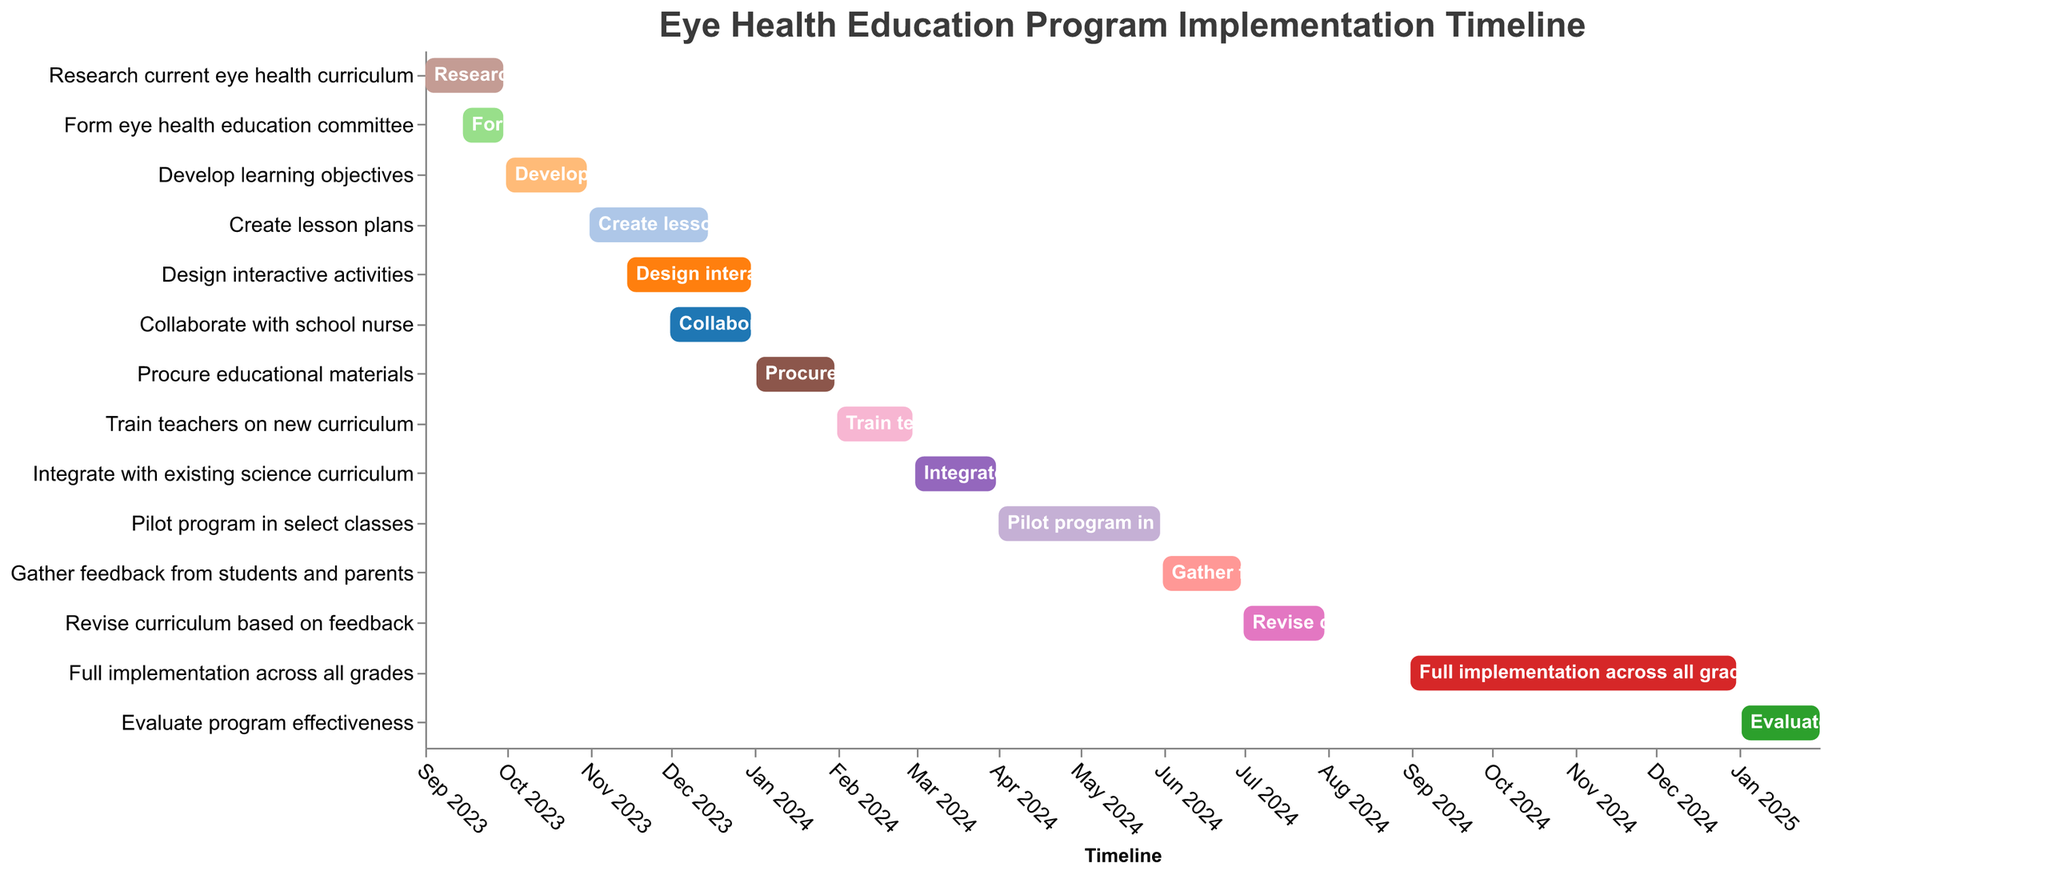What is the title of the figure? The title is usually located at the top of the figure. The title of this figure is "Eye Health Education Program Implementation Timeline".
Answer: Eye Health Education Program Implementation Timeline Which task is scheduled to start first? The task with the earliest start date is "Research current eye health curriculum," which starts on 2023-09-01.
Answer: Research current eye health curriculum When does the task "Create lesson plans" end? The task "Create lesson plans" ends on 2023-12-15, as indicated by the End Date for this task.
Answer: 2023-12-15 How many tasks are taking place in December 2023? Checking the Start and End Dates of all tasks, we see that "Create lesson plans," "Design interactive activities," and "Collaborate with school nurse" occur in December 2023.
Answer: 3 Which tasks overlap in their timeframes? Tasks that have overlapping dates include "Research current eye health curriculum" and "Form eye health education committee" (both in September 2023), "Create lesson plans" and "Design interactive activities" (both partially in November-December 2023), among others.
Answer: Research current eye health curriculum and Form eye health education committee; Create lesson plans and Design interactive activities, and more Which tasks extend over the longest period? The task "Full implementation across all grades" extends from 2024-09-01 to 2024-12-31 (4 months), which is the longest duration among all tasks.
Answer: Full implementation across all grades During what month does the task "Train teachers on new curriculum" take place? The task "Train teachers on new curriculum" is scheduled from 2024-02-01 to 2024-02-29, so it occurs entirely in February 2024.
Answer: February 2024 What is the total number of tasks that need to be completed? By counting all the tasks listed, we see there are a total of 14 tasks to be completed.
Answer: 14 When does the final task "Evaluate program effectiveness" start and end? The Start Date for "Evaluate program effectiveness" is 2025-01-02 and the End Date is 2025-01-31.
Answer: 2025-01-02 to 2025-01-31 Which tasks are scheduled to begin in January 2024? Cross-referencing the Start Dates, only "Procure educational materials" starts in January 2024 (on 2024-01-02).
Answer: Procure educational materials 